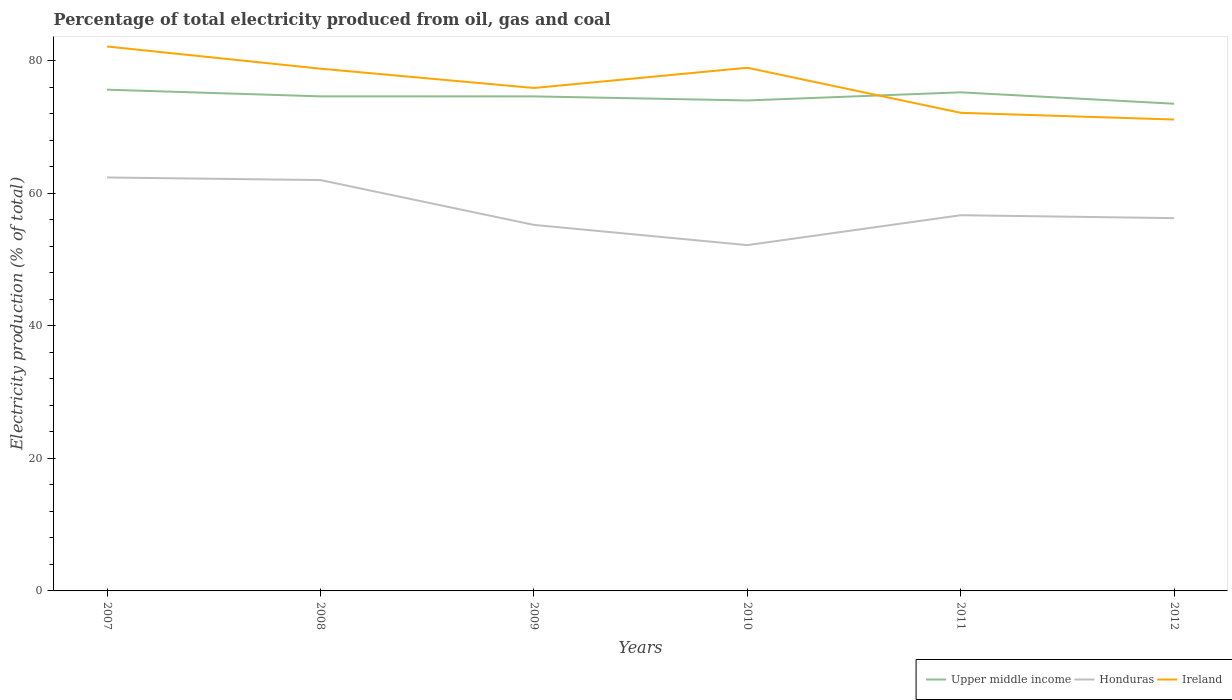Is the number of lines equal to the number of legend labels?
Offer a terse response. Yes. Across all years, what is the maximum electricity production in in Honduras?
Give a very brief answer. 52.19. In which year was the electricity production in in Ireland maximum?
Ensure brevity in your answer.  2012. What is the total electricity production in in Ireland in the graph?
Offer a terse response. 6.66. What is the difference between the highest and the second highest electricity production in in Honduras?
Make the answer very short. 10.21. Is the electricity production in in Ireland strictly greater than the electricity production in in Upper middle income over the years?
Make the answer very short. No. How many lines are there?
Your answer should be compact. 3. How many years are there in the graph?
Keep it short and to the point. 6. What is the difference between two consecutive major ticks on the Y-axis?
Your answer should be very brief. 20. Are the values on the major ticks of Y-axis written in scientific E-notation?
Offer a terse response. No. Where does the legend appear in the graph?
Provide a succinct answer. Bottom right. How many legend labels are there?
Ensure brevity in your answer.  3. How are the legend labels stacked?
Your response must be concise. Horizontal. What is the title of the graph?
Your response must be concise. Percentage of total electricity produced from oil, gas and coal. Does "India" appear as one of the legend labels in the graph?
Make the answer very short. No. What is the label or title of the Y-axis?
Ensure brevity in your answer.  Electricity production (% of total). What is the Electricity production (% of total) in Upper middle income in 2007?
Keep it short and to the point. 75.65. What is the Electricity production (% of total) in Honduras in 2007?
Make the answer very short. 62.4. What is the Electricity production (% of total) of Ireland in 2007?
Provide a short and direct response. 82.17. What is the Electricity production (% of total) in Upper middle income in 2008?
Your answer should be compact. 74.65. What is the Electricity production (% of total) in Honduras in 2008?
Your answer should be compact. 62.01. What is the Electricity production (% of total) of Ireland in 2008?
Offer a terse response. 78.82. What is the Electricity production (% of total) of Upper middle income in 2009?
Ensure brevity in your answer.  74.64. What is the Electricity production (% of total) of Honduras in 2009?
Give a very brief answer. 55.25. What is the Electricity production (% of total) of Ireland in 2009?
Keep it short and to the point. 75.91. What is the Electricity production (% of total) of Upper middle income in 2010?
Ensure brevity in your answer.  74.03. What is the Electricity production (% of total) of Honduras in 2010?
Ensure brevity in your answer.  52.19. What is the Electricity production (% of total) in Ireland in 2010?
Offer a terse response. 78.96. What is the Electricity production (% of total) in Upper middle income in 2011?
Offer a terse response. 75.25. What is the Electricity production (% of total) of Honduras in 2011?
Ensure brevity in your answer.  56.7. What is the Electricity production (% of total) of Ireland in 2011?
Your answer should be very brief. 72.16. What is the Electricity production (% of total) in Upper middle income in 2012?
Provide a succinct answer. 73.53. What is the Electricity production (% of total) of Honduras in 2012?
Make the answer very short. 56.26. What is the Electricity production (% of total) of Ireland in 2012?
Offer a very short reply. 71.15. Across all years, what is the maximum Electricity production (% of total) in Upper middle income?
Provide a short and direct response. 75.65. Across all years, what is the maximum Electricity production (% of total) in Honduras?
Offer a terse response. 62.4. Across all years, what is the maximum Electricity production (% of total) of Ireland?
Your answer should be very brief. 82.17. Across all years, what is the minimum Electricity production (% of total) in Upper middle income?
Your answer should be compact. 73.53. Across all years, what is the minimum Electricity production (% of total) in Honduras?
Ensure brevity in your answer.  52.19. Across all years, what is the minimum Electricity production (% of total) of Ireland?
Give a very brief answer. 71.15. What is the total Electricity production (% of total) of Upper middle income in the graph?
Your response must be concise. 447.74. What is the total Electricity production (% of total) in Honduras in the graph?
Make the answer very short. 344.81. What is the total Electricity production (% of total) of Ireland in the graph?
Ensure brevity in your answer.  459.17. What is the difference between the Electricity production (% of total) in Honduras in 2007 and that in 2008?
Keep it short and to the point. 0.39. What is the difference between the Electricity production (% of total) in Ireland in 2007 and that in 2008?
Make the answer very short. 3.35. What is the difference between the Electricity production (% of total) in Upper middle income in 2007 and that in 2009?
Your response must be concise. 1.01. What is the difference between the Electricity production (% of total) in Honduras in 2007 and that in 2009?
Provide a succinct answer. 7.15. What is the difference between the Electricity production (% of total) in Ireland in 2007 and that in 2009?
Ensure brevity in your answer.  6.26. What is the difference between the Electricity production (% of total) of Upper middle income in 2007 and that in 2010?
Offer a very short reply. 1.62. What is the difference between the Electricity production (% of total) of Honduras in 2007 and that in 2010?
Your answer should be very brief. 10.21. What is the difference between the Electricity production (% of total) of Ireland in 2007 and that in 2010?
Your answer should be compact. 3.21. What is the difference between the Electricity production (% of total) in Upper middle income in 2007 and that in 2011?
Give a very brief answer. 0.4. What is the difference between the Electricity production (% of total) in Honduras in 2007 and that in 2011?
Your answer should be very brief. 5.7. What is the difference between the Electricity production (% of total) in Ireland in 2007 and that in 2011?
Provide a short and direct response. 10.01. What is the difference between the Electricity production (% of total) of Upper middle income in 2007 and that in 2012?
Offer a terse response. 2.12. What is the difference between the Electricity production (% of total) of Honduras in 2007 and that in 2012?
Offer a terse response. 6.14. What is the difference between the Electricity production (% of total) of Ireland in 2007 and that in 2012?
Your answer should be very brief. 11.02. What is the difference between the Electricity production (% of total) in Upper middle income in 2008 and that in 2009?
Make the answer very short. 0.01. What is the difference between the Electricity production (% of total) in Honduras in 2008 and that in 2009?
Your answer should be very brief. 6.76. What is the difference between the Electricity production (% of total) of Ireland in 2008 and that in 2009?
Provide a succinct answer. 2.92. What is the difference between the Electricity production (% of total) of Upper middle income in 2008 and that in 2010?
Provide a succinct answer. 0.62. What is the difference between the Electricity production (% of total) in Honduras in 2008 and that in 2010?
Keep it short and to the point. 9.82. What is the difference between the Electricity production (% of total) in Ireland in 2008 and that in 2010?
Your answer should be very brief. -0.14. What is the difference between the Electricity production (% of total) in Upper middle income in 2008 and that in 2011?
Ensure brevity in your answer.  -0.61. What is the difference between the Electricity production (% of total) in Honduras in 2008 and that in 2011?
Your answer should be very brief. 5.31. What is the difference between the Electricity production (% of total) of Ireland in 2008 and that in 2011?
Offer a very short reply. 6.66. What is the difference between the Electricity production (% of total) of Upper middle income in 2008 and that in 2012?
Offer a terse response. 1.12. What is the difference between the Electricity production (% of total) of Honduras in 2008 and that in 2012?
Keep it short and to the point. 5.75. What is the difference between the Electricity production (% of total) in Ireland in 2008 and that in 2012?
Ensure brevity in your answer.  7.67. What is the difference between the Electricity production (% of total) of Upper middle income in 2009 and that in 2010?
Your answer should be very brief. 0.61. What is the difference between the Electricity production (% of total) of Honduras in 2009 and that in 2010?
Your answer should be compact. 3.05. What is the difference between the Electricity production (% of total) of Ireland in 2009 and that in 2010?
Keep it short and to the point. -3.06. What is the difference between the Electricity production (% of total) of Upper middle income in 2009 and that in 2011?
Offer a terse response. -0.61. What is the difference between the Electricity production (% of total) of Honduras in 2009 and that in 2011?
Offer a terse response. -1.46. What is the difference between the Electricity production (% of total) in Ireland in 2009 and that in 2011?
Offer a very short reply. 3.75. What is the difference between the Electricity production (% of total) of Upper middle income in 2009 and that in 2012?
Provide a short and direct response. 1.11. What is the difference between the Electricity production (% of total) in Honduras in 2009 and that in 2012?
Offer a terse response. -1.02. What is the difference between the Electricity production (% of total) in Ireland in 2009 and that in 2012?
Offer a terse response. 4.76. What is the difference between the Electricity production (% of total) of Upper middle income in 2010 and that in 2011?
Ensure brevity in your answer.  -1.23. What is the difference between the Electricity production (% of total) of Honduras in 2010 and that in 2011?
Keep it short and to the point. -4.51. What is the difference between the Electricity production (% of total) of Ireland in 2010 and that in 2011?
Your answer should be very brief. 6.8. What is the difference between the Electricity production (% of total) of Upper middle income in 2010 and that in 2012?
Offer a terse response. 0.49. What is the difference between the Electricity production (% of total) in Honduras in 2010 and that in 2012?
Provide a short and direct response. -4.07. What is the difference between the Electricity production (% of total) of Ireland in 2010 and that in 2012?
Make the answer very short. 7.82. What is the difference between the Electricity production (% of total) in Upper middle income in 2011 and that in 2012?
Your response must be concise. 1.72. What is the difference between the Electricity production (% of total) of Honduras in 2011 and that in 2012?
Make the answer very short. 0.44. What is the difference between the Electricity production (% of total) of Ireland in 2011 and that in 2012?
Ensure brevity in your answer.  1.01. What is the difference between the Electricity production (% of total) of Upper middle income in 2007 and the Electricity production (% of total) of Honduras in 2008?
Offer a very short reply. 13.64. What is the difference between the Electricity production (% of total) in Upper middle income in 2007 and the Electricity production (% of total) in Ireland in 2008?
Provide a short and direct response. -3.17. What is the difference between the Electricity production (% of total) in Honduras in 2007 and the Electricity production (% of total) in Ireland in 2008?
Make the answer very short. -16.42. What is the difference between the Electricity production (% of total) of Upper middle income in 2007 and the Electricity production (% of total) of Honduras in 2009?
Provide a succinct answer. 20.4. What is the difference between the Electricity production (% of total) of Upper middle income in 2007 and the Electricity production (% of total) of Ireland in 2009?
Your answer should be very brief. -0.26. What is the difference between the Electricity production (% of total) of Honduras in 2007 and the Electricity production (% of total) of Ireland in 2009?
Offer a terse response. -13.51. What is the difference between the Electricity production (% of total) of Upper middle income in 2007 and the Electricity production (% of total) of Honduras in 2010?
Make the answer very short. 23.46. What is the difference between the Electricity production (% of total) of Upper middle income in 2007 and the Electricity production (% of total) of Ireland in 2010?
Offer a very short reply. -3.31. What is the difference between the Electricity production (% of total) in Honduras in 2007 and the Electricity production (% of total) in Ireland in 2010?
Make the answer very short. -16.56. What is the difference between the Electricity production (% of total) of Upper middle income in 2007 and the Electricity production (% of total) of Honduras in 2011?
Ensure brevity in your answer.  18.95. What is the difference between the Electricity production (% of total) in Upper middle income in 2007 and the Electricity production (% of total) in Ireland in 2011?
Make the answer very short. 3.49. What is the difference between the Electricity production (% of total) in Honduras in 2007 and the Electricity production (% of total) in Ireland in 2011?
Offer a terse response. -9.76. What is the difference between the Electricity production (% of total) of Upper middle income in 2007 and the Electricity production (% of total) of Honduras in 2012?
Make the answer very short. 19.39. What is the difference between the Electricity production (% of total) of Upper middle income in 2007 and the Electricity production (% of total) of Ireland in 2012?
Provide a succinct answer. 4.5. What is the difference between the Electricity production (% of total) in Honduras in 2007 and the Electricity production (% of total) in Ireland in 2012?
Your response must be concise. -8.75. What is the difference between the Electricity production (% of total) in Upper middle income in 2008 and the Electricity production (% of total) in Honduras in 2009?
Your answer should be compact. 19.4. What is the difference between the Electricity production (% of total) in Upper middle income in 2008 and the Electricity production (% of total) in Ireland in 2009?
Keep it short and to the point. -1.26. What is the difference between the Electricity production (% of total) in Honduras in 2008 and the Electricity production (% of total) in Ireland in 2009?
Ensure brevity in your answer.  -13.9. What is the difference between the Electricity production (% of total) of Upper middle income in 2008 and the Electricity production (% of total) of Honduras in 2010?
Keep it short and to the point. 22.46. What is the difference between the Electricity production (% of total) in Upper middle income in 2008 and the Electricity production (% of total) in Ireland in 2010?
Make the answer very short. -4.32. What is the difference between the Electricity production (% of total) in Honduras in 2008 and the Electricity production (% of total) in Ireland in 2010?
Offer a terse response. -16.95. What is the difference between the Electricity production (% of total) of Upper middle income in 2008 and the Electricity production (% of total) of Honduras in 2011?
Keep it short and to the point. 17.94. What is the difference between the Electricity production (% of total) in Upper middle income in 2008 and the Electricity production (% of total) in Ireland in 2011?
Your answer should be very brief. 2.49. What is the difference between the Electricity production (% of total) in Honduras in 2008 and the Electricity production (% of total) in Ireland in 2011?
Ensure brevity in your answer.  -10.15. What is the difference between the Electricity production (% of total) of Upper middle income in 2008 and the Electricity production (% of total) of Honduras in 2012?
Your answer should be compact. 18.38. What is the difference between the Electricity production (% of total) of Upper middle income in 2008 and the Electricity production (% of total) of Ireland in 2012?
Provide a succinct answer. 3.5. What is the difference between the Electricity production (% of total) in Honduras in 2008 and the Electricity production (% of total) in Ireland in 2012?
Give a very brief answer. -9.14. What is the difference between the Electricity production (% of total) in Upper middle income in 2009 and the Electricity production (% of total) in Honduras in 2010?
Your answer should be very brief. 22.45. What is the difference between the Electricity production (% of total) of Upper middle income in 2009 and the Electricity production (% of total) of Ireland in 2010?
Ensure brevity in your answer.  -4.32. What is the difference between the Electricity production (% of total) of Honduras in 2009 and the Electricity production (% of total) of Ireland in 2010?
Ensure brevity in your answer.  -23.72. What is the difference between the Electricity production (% of total) of Upper middle income in 2009 and the Electricity production (% of total) of Honduras in 2011?
Ensure brevity in your answer.  17.94. What is the difference between the Electricity production (% of total) in Upper middle income in 2009 and the Electricity production (% of total) in Ireland in 2011?
Your answer should be compact. 2.48. What is the difference between the Electricity production (% of total) of Honduras in 2009 and the Electricity production (% of total) of Ireland in 2011?
Ensure brevity in your answer.  -16.92. What is the difference between the Electricity production (% of total) of Upper middle income in 2009 and the Electricity production (% of total) of Honduras in 2012?
Ensure brevity in your answer.  18.38. What is the difference between the Electricity production (% of total) of Upper middle income in 2009 and the Electricity production (% of total) of Ireland in 2012?
Provide a succinct answer. 3.49. What is the difference between the Electricity production (% of total) in Honduras in 2009 and the Electricity production (% of total) in Ireland in 2012?
Provide a short and direct response. -15.9. What is the difference between the Electricity production (% of total) of Upper middle income in 2010 and the Electricity production (% of total) of Honduras in 2011?
Provide a succinct answer. 17.32. What is the difference between the Electricity production (% of total) in Upper middle income in 2010 and the Electricity production (% of total) in Ireland in 2011?
Offer a terse response. 1.86. What is the difference between the Electricity production (% of total) of Honduras in 2010 and the Electricity production (% of total) of Ireland in 2011?
Offer a terse response. -19.97. What is the difference between the Electricity production (% of total) in Upper middle income in 2010 and the Electricity production (% of total) in Honduras in 2012?
Offer a very short reply. 17.76. What is the difference between the Electricity production (% of total) in Upper middle income in 2010 and the Electricity production (% of total) in Ireland in 2012?
Your response must be concise. 2.88. What is the difference between the Electricity production (% of total) of Honduras in 2010 and the Electricity production (% of total) of Ireland in 2012?
Ensure brevity in your answer.  -18.96. What is the difference between the Electricity production (% of total) of Upper middle income in 2011 and the Electricity production (% of total) of Honduras in 2012?
Your answer should be compact. 18.99. What is the difference between the Electricity production (% of total) in Upper middle income in 2011 and the Electricity production (% of total) in Ireland in 2012?
Ensure brevity in your answer.  4.11. What is the difference between the Electricity production (% of total) in Honduras in 2011 and the Electricity production (% of total) in Ireland in 2012?
Provide a succinct answer. -14.44. What is the average Electricity production (% of total) of Upper middle income per year?
Give a very brief answer. 74.62. What is the average Electricity production (% of total) of Honduras per year?
Make the answer very short. 57.47. What is the average Electricity production (% of total) of Ireland per year?
Provide a succinct answer. 76.53. In the year 2007, what is the difference between the Electricity production (% of total) in Upper middle income and Electricity production (% of total) in Honduras?
Offer a terse response. 13.25. In the year 2007, what is the difference between the Electricity production (% of total) of Upper middle income and Electricity production (% of total) of Ireland?
Give a very brief answer. -6.52. In the year 2007, what is the difference between the Electricity production (% of total) in Honduras and Electricity production (% of total) in Ireland?
Your response must be concise. -19.77. In the year 2008, what is the difference between the Electricity production (% of total) of Upper middle income and Electricity production (% of total) of Honduras?
Your response must be concise. 12.64. In the year 2008, what is the difference between the Electricity production (% of total) of Upper middle income and Electricity production (% of total) of Ireland?
Give a very brief answer. -4.17. In the year 2008, what is the difference between the Electricity production (% of total) in Honduras and Electricity production (% of total) in Ireland?
Your response must be concise. -16.81. In the year 2009, what is the difference between the Electricity production (% of total) of Upper middle income and Electricity production (% of total) of Honduras?
Provide a succinct answer. 19.39. In the year 2009, what is the difference between the Electricity production (% of total) of Upper middle income and Electricity production (% of total) of Ireland?
Offer a terse response. -1.27. In the year 2009, what is the difference between the Electricity production (% of total) of Honduras and Electricity production (% of total) of Ireland?
Your answer should be very brief. -20.66. In the year 2010, what is the difference between the Electricity production (% of total) of Upper middle income and Electricity production (% of total) of Honduras?
Offer a terse response. 21.83. In the year 2010, what is the difference between the Electricity production (% of total) in Upper middle income and Electricity production (% of total) in Ireland?
Keep it short and to the point. -4.94. In the year 2010, what is the difference between the Electricity production (% of total) of Honduras and Electricity production (% of total) of Ireland?
Provide a short and direct response. -26.77. In the year 2011, what is the difference between the Electricity production (% of total) in Upper middle income and Electricity production (% of total) in Honduras?
Keep it short and to the point. 18.55. In the year 2011, what is the difference between the Electricity production (% of total) of Upper middle income and Electricity production (% of total) of Ireland?
Ensure brevity in your answer.  3.09. In the year 2011, what is the difference between the Electricity production (% of total) of Honduras and Electricity production (% of total) of Ireland?
Your answer should be compact. -15.46. In the year 2012, what is the difference between the Electricity production (% of total) in Upper middle income and Electricity production (% of total) in Honduras?
Give a very brief answer. 17.27. In the year 2012, what is the difference between the Electricity production (% of total) of Upper middle income and Electricity production (% of total) of Ireland?
Your answer should be very brief. 2.38. In the year 2012, what is the difference between the Electricity production (% of total) of Honduras and Electricity production (% of total) of Ireland?
Make the answer very short. -14.88. What is the ratio of the Electricity production (% of total) in Upper middle income in 2007 to that in 2008?
Your answer should be very brief. 1.01. What is the ratio of the Electricity production (% of total) of Honduras in 2007 to that in 2008?
Give a very brief answer. 1.01. What is the ratio of the Electricity production (% of total) of Ireland in 2007 to that in 2008?
Give a very brief answer. 1.04. What is the ratio of the Electricity production (% of total) in Upper middle income in 2007 to that in 2009?
Your answer should be compact. 1.01. What is the ratio of the Electricity production (% of total) in Honduras in 2007 to that in 2009?
Your answer should be very brief. 1.13. What is the ratio of the Electricity production (% of total) in Ireland in 2007 to that in 2009?
Provide a short and direct response. 1.08. What is the ratio of the Electricity production (% of total) of Upper middle income in 2007 to that in 2010?
Your response must be concise. 1.02. What is the ratio of the Electricity production (% of total) of Honduras in 2007 to that in 2010?
Make the answer very short. 1.2. What is the ratio of the Electricity production (% of total) in Ireland in 2007 to that in 2010?
Give a very brief answer. 1.04. What is the ratio of the Electricity production (% of total) of Honduras in 2007 to that in 2011?
Keep it short and to the point. 1.1. What is the ratio of the Electricity production (% of total) of Ireland in 2007 to that in 2011?
Give a very brief answer. 1.14. What is the ratio of the Electricity production (% of total) in Upper middle income in 2007 to that in 2012?
Ensure brevity in your answer.  1.03. What is the ratio of the Electricity production (% of total) of Honduras in 2007 to that in 2012?
Provide a short and direct response. 1.11. What is the ratio of the Electricity production (% of total) of Ireland in 2007 to that in 2012?
Keep it short and to the point. 1.15. What is the ratio of the Electricity production (% of total) in Honduras in 2008 to that in 2009?
Make the answer very short. 1.12. What is the ratio of the Electricity production (% of total) of Ireland in 2008 to that in 2009?
Your answer should be very brief. 1.04. What is the ratio of the Electricity production (% of total) in Upper middle income in 2008 to that in 2010?
Give a very brief answer. 1.01. What is the ratio of the Electricity production (% of total) of Honduras in 2008 to that in 2010?
Ensure brevity in your answer.  1.19. What is the ratio of the Electricity production (% of total) of Ireland in 2008 to that in 2010?
Keep it short and to the point. 1. What is the ratio of the Electricity production (% of total) of Upper middle income in 2008 to that in 2011?
Keep it short and to the point. 0.99. What is the ratio of the Electricity production (% of total) of Honduras in 2008 to that in 2011?
Give a very brief answer. 1.09. What is the ratio of the Electricity production (% of total) in Ireland in 2008 to that in 2011?
Offer a very short reply. 1.09. What is the ratio of the Electricity production (% of total) in Upper middle income in 2008 to that in 2012?
Keep it short and to the point. 1.02. What is the ratio of the Electricity production (% of total) in Honduras in 2008 to that in 2012?
Offer a very short reply. 1.1. What is the ratio of the Electricity production (% of total) in Ireland in 2008 to that in 2012?
Ensure brevity in your answer.  1.11. What is the ratio of the Electricity production (% of total) of Upper middle income in 2009 to that in 2010?
Ensure brevity in your answer.  1.01. What is the ratio of the Electricity production (% of total) of Honduras in 2009 to that in 2010?
Provide a short and direct response. 1.06. What is the ratio of the Electricity production (% of total) of Ireland in 2009 to that in 2010?
Keep it short and to the point. 0.96. What is the ratio of the Electricity production (% of total) in Upper middle income in 2009 to that in 2011?
Provide a short and direct response. 0.99. What is the ratio of the Electricity production (% of total) in Honduras in 2009 to that in 2011?
Provide a short and direct response. 0.97. What is the ratio of the Electricity production (% of total) in Ireland in 2009 to that in 2011?
Ensure brevity in your answer.  1.05. What is the ratio of the Electricity production (% of total) in Upper middle income in 2009 to that in 2012?
Give a very brief answer. 1.02. What is the ratio of the Electricity production (% of total) of Honduras in 2009 to that in 2012?
Offer a very short reply. 0.98. What is the ratio of the Electricity production (% of total) of Ireland in 2009 to that in 2012?
Your response must be concise. 1.07. What is the ratio of the Electricity production (% of total) of Upper middle income in 2010 to that in 2011?
Your response must be concise. 0.98. What is the ratio of the Electricity production (% of total) in Honduras in 2010 to that in 2011?
Your answer should be very brief. 0.92. What is the ratio of the Electricity production (% of total) in Ireland in 2010 to that in 2011?
Give a very brief answer. 1.09. What is the ratio of the Electricity production (% of total) of Upper middle income in 2010 to that in 2012?
Make the answer very short. 1.01. What is the ratio of the Electricity production (% of total) in Honduras in 2010 to that in 2012?
Keep it short and to the point. 0.93. What is the ratio of the Electricity production (% of total) of Ireland in 2010 to that in 2012?
Provide a succinct answer. 1.11. What is the ratio of the Electricity production (% of total) in Upper middle income in 2011 to that in 2012?
Keep it short and to the point. 1.02. What is the ratio of the Electricity production (% of total) in Honduras in 2011 to that in 2012?
Ensure brevity in your answer.  1.01. What is the ratio of the Electricity production (% of total) in Ireland in 2011 to that in 2012?
Provide a succinct answer. 1.01. What is the difference between the highest and the second highest Electricity production (% of total) of Upper middle income?
Offer a very short reply. 0.4. What is the difference between the highest and the second highest Electricity production (% of total) in Honduras?
Your answer should be compact. 0.39. What is the difference between the highest and the second highest Electricity production (% of total) of Ireland?
Provide a short and direct response. 3.21. What is the difference between the highest and the lowest Electricity production (% of total) of Upper middle income?
Your answer should be compact. 2.12. What is the difference between the highest and the lowest Electricity production (% of total) of Honduras?
Your answer should be very brief. 10.21. What is the difference between the highest and the lowest Electricity production (% of total) of Ireland?
Provide a short and direct response. 11.02. 